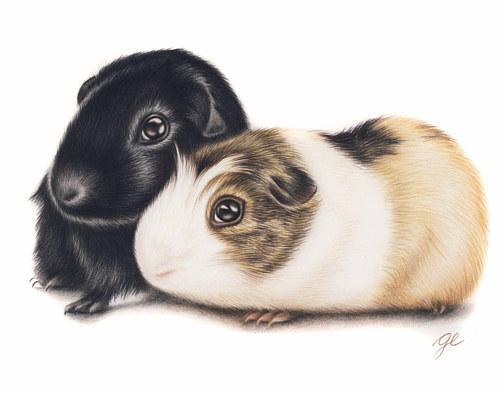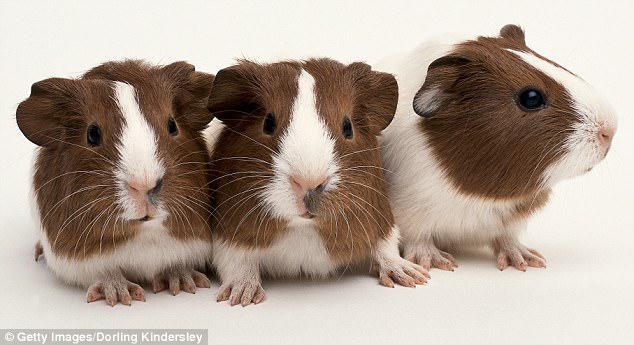The first image is the image on the left, the second image is the image on the right. Evaluate the accuracy of this statement regarding the images: "There are  4 guinea pigs in the pair". Is it true? Answer yes or no. No. The first image is the image on the left, the second image is the image on the right. Considering the images on both sides, is "One of the images shows exactly four furry animals." valid? Answer yes or no. No. 